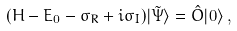Convert formula to latex. <formula><loc_0><loc_0><loc_500><loc_500>( H - E _ { 0 } - \sigma _ { R } + i \sigma _ { I } ) | \tilde { \Psi } \rangle = \hat { O } | 0 \rangle \, ,</formula> 